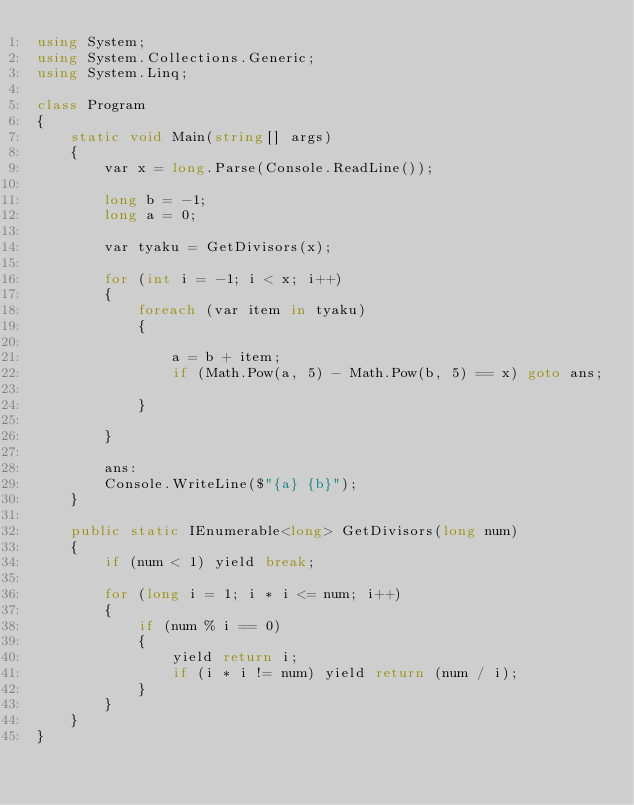<code> <loc_0><loc_0><loc_500><loc_500><_C#_>using System;
using System.Collections.Generic;
using System.Linq;

class Program
{
    static void Main(string[] args)
    {
        var x = long.Parse(Console.ReadLine());

        long b = -1;
        long a = 0;

        var tyaku = GetDivisors(x);

        for (int i = -1; i < x; i++)
        {
            foreach (var item in tyaku)
            {

                a = b + item;
                if (Math.Pow(a, 5) - Math.Pow(b, 5) == x) goto ans;

            }

        }

        ans: 
        Console.WriteLine($"{a} {b}");
    }

    public static IEnumerable<long> GetDivisors(long num)
    {
        if (num < 1) yield break;

        for (long i = 1; i * i <= num; i++)
        {
            if (num % i == 0)
            {
                yield return i;
                if (i * i != num) yield return (num / i);
            }
        }
    }
}</code> 